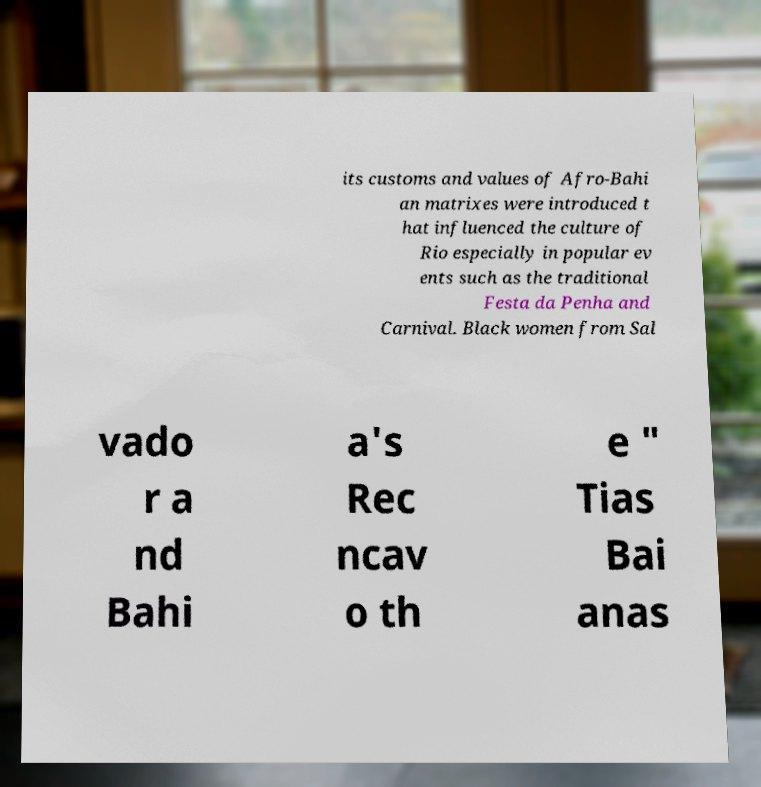Please identify and transcribe the text found in this image. its customs and values of Afro-Bahi an matrixes were introduced t hat influenced the culture of Rio especially in popular ev ents such as the traditional Festa da Penha and Carnival. Black women from Sal vado r a nd Bahi a's Rec ncav o th e " Tias Bai anas 